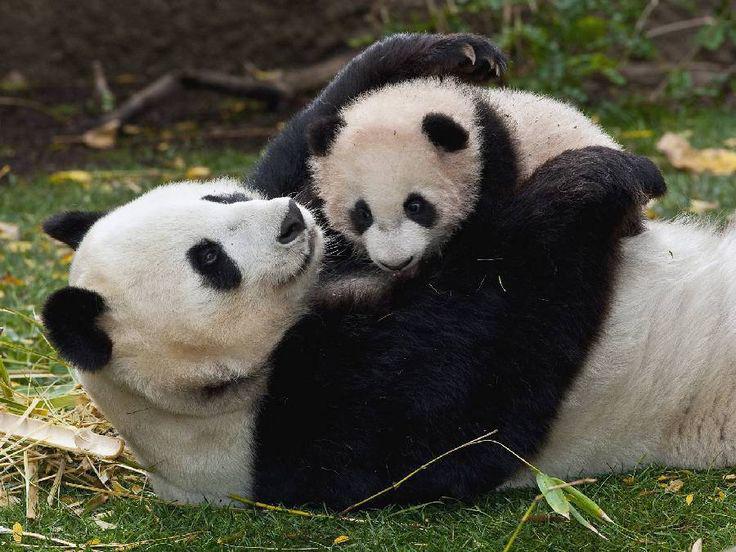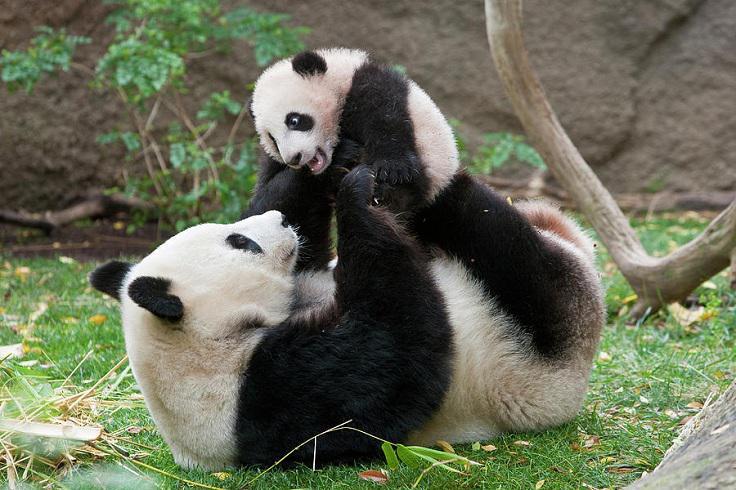The first image is the image on the left, the second image is the image on the right. Analyze the images presented: Is the assertion "Two pandas are actively play-fighting in one image, and the other image contains two pandas who are not in direct contact." valid? Answer yes or no. No. The first image is the image on the left, the second image is the image on the right. Considering the images on both sides, is "a mother panda is with her infant on the grass" valid? Answer yes or no. Yes. 